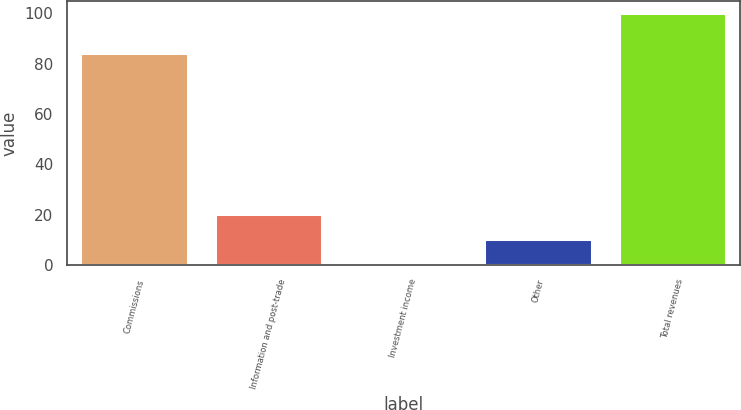Convert chart to OTSL. <chart><loc_0><loc_0><loc_500><loc_500><bar_chart><fcel>Commissions<fcel>Information and post-trade<fcel>Investment income<fcel>Other<fcel>Total revenues<nl><fcel>84.2<fcel>20.16<fcel>0.2<fcel>10.18<fcel>100<nl></chart> 